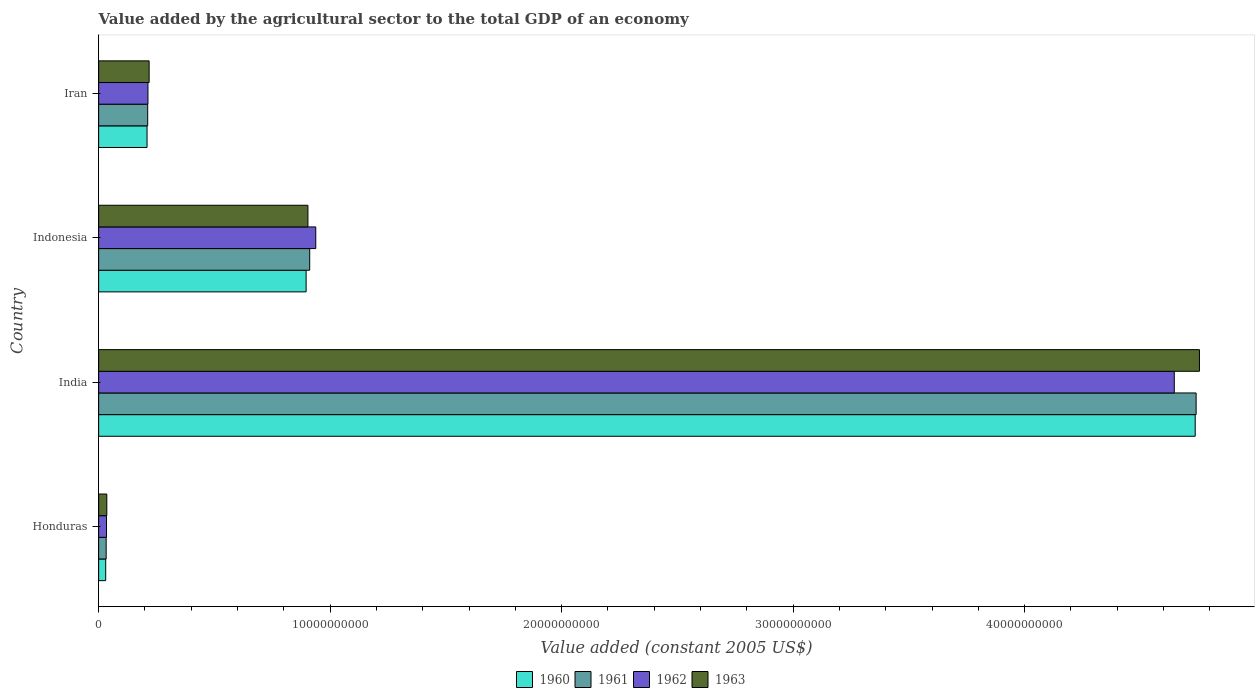How many bars are there on the 2nd tick from the bottom?
Your answer should be compact. 4. What is the label of the 4th group of bars from the top?
Give a very brief answer. Honduras. What is the value added by the agricultural sector in 1961 in Indonesia?
Offer a terse response. 9.12e+09. Across all countries, what is the maximum value added by the agricultural sector in 1963?
Ensure brevity in your answer.  4.76e+1. Across all countries, what is the minimum value added by the agricultural sector in 1961?
Provide a short and direct response. 3.25e+08. In which country was the value added by the agricultural sector in 1961 minimum?
Your response must be concise. Honduras. What is the total value added by the agricultural sector in 1963 in the graph?
Keep it short and to the point. 5.91e+1. What is the difference between the value added by the agricultural sector in 1963 in Honduras and that in Iran?
Provide a succinct answer. -1.83e+09. What is the difference between the value added by the agricultural sector in 1961 in India and the value added by the agricultural sector in 1962 in Indonesia?
Keep it short and to the point. 3.80e+1. What is the average value added by the agricultural sector in 1963 per country?
Offer a very short reply. 1.48e+1. What is the difference between the value added by the agricultural sector in 1961 and value added by the agricultural sector in 1962 in Indonesia?
Ensure brevity in your answer.  -2.62e+08. In how many countries, is the value added by the agricultural sector in 1963 greater than 42000000000 US$?
Provide a succinct answer. 1. What is the ratio of the value added by the agricultural sector in 1962 in Honduras to that in Indonesia?
Offer a terse response. 0.04. Is the difference between the value added by the agricultural sector in 1961 in Honduras and India greater than the difference between the value added by the agricultural sector in 1962 in Honduras and India?
Offer a terse response. No. What is the difference between the highest and the second highest value added by the agricultural sector in 1961?
Ensure brevity in your answer.  3.83e+1. What is the difference between the highest and the lowest value added by the agricultural sector in 1961?
Your response must be concise. 4.71e+1. In how many countries, is the value added by the agricultural sector in 1960 greater than the average value added by the agricultural sector in 1960 taken over all countries?
Your answer should be very brief. 1. Is it the case that in every country, the sum of the value added by the agricultural sector in 1961 and value added by the agricultural sector in 1960 is greater than the sum of value added by the agricultural sector in 1962 and value added by the agricultural sector in 1963?
Your answer should be compact. No. What does the 1st bar from the top in India represents?
Your response must be concise. 1963. What does the 3rd bar from the bottom in Iran represents?
Your response must be concise. 1962. How many countries are there in the graph?
Your response must be concise. 4. What is the difference between two consecutive major ticks on the X-axis?
Provide a succinct answer. 1.00e+1. How are the legend labels stacked?
Ensure brevity in your answer.  Horizontal. What is the title of the graph?
Give a very brief answer. Value added by the agricultural sector to the total GDP of an economy. Does "1984" appear as one of the legend labels in the graph?
Your answer should be compact. No. What is the label or title of the X-axis?
Provide a short and direct response. Value added (constant 2005 US$). What is the label or title of the Y-axis?
Make the answer very short. Country. What is the Value added (constant 2005 US$) of 1960 in Honduras?
Offer a terse response. 3.05e+08. What is the Value added (constant 2005 US$) of 1961 in Honduras?
Offer a terse response. 3.25e+08. What is the Value added (constant 2005 US$) in 1962 in Honduras?
Give a very brief answer. 3.41e+08. What is the Value added (constant 2005 US$) of 1963 in Honduras?
Your response must be concise. 3.53e+08. What is the Value added (constant 2005 US$) of 1960 in India?
Provide a short and direct response. 4.74e+1. What is the Value added (constant 2005 US$) in 1961 in India?
Make the answer very short. 4.74e+1. What is the Value added (constant 2005 US$) in 1962 in India?
Give a very brief answer. 4.65e+1. What is the Value added (constant 2005 US$) of 1963 in India?
Ensure brevity in your answer.  4.76e+1. What is the Value added (constant 2005 US$) of 1960 in Indonesia?
Offer a very short reply. 8.96e+09. What is the Value added (constant 2005 US$) of 1961 in Indonesia?
Your response must be concise. 9.12e+09. What is the Value added (constant 2005 US$) of 1962 in Indonesia?
Make the answer very short. 9.38e+09. What is the Value added (constant 2005 US$) of 1963 in Indonesia?
Ensure brevity in your answer.  9.04e+09. What is the Value added (constant 2005 US$) of 1960 in Iran?
Offer a terse response. 2.09e+09. What is the Value added (constant 2005 US$) of 1961 in Iran?
Provide a succinct answer. 2.12e+09. What is the Value added (constant 2005 US$) in 1962 in Iran?
Ensure brevity in your answer.  2.13e+09. What is the Value added (constant 2005 US$) in 1963 in Iran?
Ensure brevity in your answer.  2.18e+09. Across all countries, what is the maximum Value added (constant 2005 US$) in 1960?
Keep it short and to the point. 4.74e+1. Across all countries, what is the maximum Value added (constant 2005 US$) of 1961?
Offer a terse response. 4.74e+1. Across all countries, what is the maximum Value added (constant 2005 US$) in 1962?
Keep it short and to the point. 4.65e+1. Across all countries, what is the maximum Value added (constant 2005 US$) in 1963?
Keep it short and to the point. 4.76e+1. Across all countries, what is the minimum Value added (constant 2005 US$) in 1960?
Keep it short and to the point. 3.05e+08. Across all countries, what is the minimum Value added (constant 2005 US$) in 1961?
Your response must be concise. 3.25e+08. Across all countries, what is the minimum Value added (constant 2005 US$) in 1962?
Your answer should be very brief. 3.41e+08. Across all countries, what is the minimum Value added (constant 2005 US$) in 1963?
Offer a terse response. 3.53e+08. What is the total Value added (constant 2005 US$) in 1960 in the graph?
Your answer should be compact. 5.87e+1. What is the total Value added (constant 2005 US$) of 1961 in the graph?
Your answer should be very brief. 5.90e+1. What is the total Value added (constant 2005 US$) in 1962 in the graph?
Your answer should be very brief. 5.83e+1. What is the total Value added (constant 2005 US$) of 1963 in the graph?
Offer a very short reply. 5.91e+1. What is the difference between the Value added (constant 2005 US$) in 1960 in Honduras and that in India?
Make the answer very short. -4.71e+1. What is the difference between the Value added (constant 2005 US$) in 1961 in Honduras and that in India?
Make the answer very short. -4.71e+1. What is the difference between the Value added (constant 2005 US$) of 1962 in Honduras and that in India?
Keep it short and to the point. -4.61e+1. What is the difference between the Value added (constant 2005 US$) in 1963 in Honduras and that in India?
Your response must be concise. -4.72e+1. What is the difference between the Value added (constant 2005 US$) in 1960 in Honduras and that in Indonesia?
Your answer should be compact. -8.66e+09. What is the difference between the Value added (constant 2005 US$) in 1961 in Honduras and that in Indonesia?
Keep it short and to the point. -8.79e+09. What is the difference between the Value added (constant 2005 US$) of 1962 in Honduras and that in Indonesia?
Keep it short and to the point. -9.04e+09. What is the difference between the Value added (constant 2005 US$) of 1963 in Honduras and that in Indonesia?
Provide a short and direct response. -8.69e+09. What is the difference between the Value added (constant 2005 US$) of 1960 in Honduras and that in Iran?
Keep it short and to the point. -1.79e+09. What is the difference between the Value added (constant 2005 US$) in 1961 in Honduras and that in Iran?
Make the answer very short. -1.79e+09. What is the difference between the Value added (constant 2005 US$) in 1962 in Honduras and that in Iran?
Make the answer very short. -1.79e+09. What is the difference between the Value added (constant 2005 US$) of 1963 in Honduras and that in Iran?
Keep it short and to the point. -1.83e+09. What is the difference between the Value added (constant 2005 US$) in 1960 in India and that in Indonesia?
Your response must be concise. 3.84e+1. What is the difference between the Value added (constant 2005 US$) of 1961 in India and that in Indonesia?
Offer a very short reply. 3.83e+1. What is the difference between the Value added (constant 2005 US$) of 1962 in India and that in Indonesia?
Ensure brevity in your answer.  3.71e+1. What is the difference between the Value added (constant 2005 US$) in 1963 in India and that in Indonesia?
Offer a terse response. 3.85e+1. What is the difference between the Value added (constant 2005 US$) in 1960 in India and that in Iran?
Your answer should be compact. 4.53e+1. What is the difference between the Value added (constant 2005 US$) in 1961 in India and that in Iran?
Provide a succinct answer. 4.53e+1. What is the difference between the Value added (constant 2005 US$) in 1962 in India and that in Iran?
Provide a short and direct response. 4.43e+1. What is the difference between the Value added (constant 2005 US$) in 1963 in India and that in Iran?
Offer a terse response. 4.54e+1. What is the difference between the Value added (constant 2005 US$) of 1960 in Indonesia and that in Iran?
Your response must be concise. 6.87e+09. What is the difference between the Value added (constant 2005 US$) in 1961 in Indonesia and that in Iran?
Your answer should be compact. 7.00e+09. What is the difference between the Value added (constant 2005 US$) of 1962 in Indonesia and that in Iran?
Offer a very short reply. 7.25e+09. What is the difference between the Value added (constant 2005 US$) of 1963 in Indonesia and that in Iran?
Your answer should be very brief. 6.86e+09. What is the difference between the Value added (constant 2005 US$) in 1960 in Honduras and the Value added (constant 2005 US$) in 1961 in India?
Provide a succinct answer. -4.71e+1. What is the difference between the Value added (constant 2005 US$) of 1960 in Honduras and the Value added (constant 2005 US$) of 1962 in India?
Provide a succinct answer. -4.62e+1. What is the difference between the Value added (constant 2005 US$) in 1960 in Honduras and the Value added (constant 2005 US$) in 1963 in India?
Provide a short and direct response. -4.72e+1. What is the difference between the Value added (constant 2005 US$) in 1961 in Honduras and the Value added (constant 2005 US$) in 1962 in India?
Your answer should be very brief. -4.61e+1. What is the difference between the Value added (constant 2005 US$) of 1961 in Honduras and the Value added (constant 2005 US$) of 1963 in India?
Provide a succinct answer. -4.72e+1. What is the difference between the Value added (constant 2005 US$) of 1962 in Honduras and the Value added (constant 2005 US$) of 1963 in India?
Offer a terse response. -4.72e+1. What is the difference between the Value added (constant 2005 US$) in 1960 in Honduras and the Value added (constant 2005 US$) in 1961 in Indonesia?
Your answer should be compact. -8.81e+09. What is the difference between the Value added (constant 2005 US$) in 1960 in Honduras and the Value added (constant 2005 US$) in 1962 in Indonesia?
Offer a terse response. -9.07e+09. What is the difference between the Value added (constant 2005 US$) of 1960 in Honduras and the Value added (constant 2005 US$) of 1963 in Indonesia?
Your response must be concise. -8.73e+09. What is the difference between the Value added (constant 2005 US$) in 1961 in Honduras and the Value added (constant 2005 US$) in 1962 in Indonesia?
Keep it short and to the point. -9.05e+09. What is the difference between the Value added (constant 2005 US$) in 1961 in Honduras and the Value added (constant 2005 US$) in 1963 in Indonesia?
Ensure brevity in your answer.  -8.72e+09. What is the difference between the Value added (constant 2005 US$) of 1962 in Honduras and the Value added (constant 2005 US$) of 1963 in Indonesia?
Offer a very short reply. -8.70e+09. What is the difference between the Value added (constant 2005 US$) of 1960 in Honduras and the Value added (constant 2005 US$) of 1961 in Iran?
Ensure brevity in your answer.  -1.81e+09. What is the difference between the Value added (constant 2005 US$) of 1960 in Honduras and the Value added (constant 2005 US$) of 1962 in Iran?
Offer a terse response. -1.82e+09. What is the difference between the Value added (constant 2005 US$) of 1960 in Honduras and the Value added (constant 2005 US$) of 1963 in Iran?
Make the answer very short. -1.88e+09. What is the difference between the Value added (constant 2005 US$) of 1961 in Honduras and the Value added (constant 2005 US$) of 1962 in Iran?
Make the answer very short. -1.80e+09. What is the difference between the Value added (constant 2005 US$) in 1961 in Honduras and the Value added (constant 2005 US$) in 1963 in Iran?
Offer a terse response. -1.86e+09. What is the difference between the Value added (constant 2005 US$) in 1962 in Honduras and the Value added (constant 2005 US$) in 1963 in Iran?
Provide a short and direct response. -1.84e+09. What is the difference between the Value added (constant 2005 US$) in 1960 in India and the Value added (constant 2005 US$) in 1961 in Indonesia?
Ensure brevity in your answer.  3.83e+1. What is the difference between the Value added (constant 2005 US$) in 1960 in India and the Value added (constant 2005 US$) in 1962 in Indonesia?
Provide a short and direct response. 3.80e+1. What is the difference between the Value added (constant 2005 US$) in 1960 in India and the Value added (constant 2005 US$) in 1963 in Indonesia?
Provide a short and direct response. 3.83e+1. What is the difference between the Value added (constant 2005 US$) of 1961 in India and the Value added (constant 2005 US$) of 1962 in Indonesia?
Offer a very short reply. 3.80e+1. What is the difference between the Value added (constant 2005 US$) in 1961 in India and the Value added (constant 2005 US$) in 1963 in Indonesia?
Provide a succinct answer. 3.84e+1. What is the difference between the Value added (constant 2005 US$) of 1962 in India and the Value added (constant 2005 US$) of 1963 in Indonesia?
Ensure brevity in your answer.  3.74e+1. What is the difference between the Value added (constant 2005 US$) in 1960 in India and the Value added (constant 2005 US$) in 1961 in Iran?
Make the answer very short. 4.52e+1. What is the difference between the Value added (constant 2005 US$) in 1960 in India and the Value added (constant 2005 US$) in 1962 in Iran?
Keep it short and to the point. 4.52e+1. What is the difference between the Value added (constant 2005 US$) in 1960 in India and the Value added (constant 2005 US$) in 1963 in Iran?
Your answer should be compact. 4.52e+1. What is the difference between the Value added (constant 2005 US$) in 1961 in India and the Value added (constant 2005 US$) in 1962 in Iran?
Your response must be concise. 4.53e+1. What is the difference between the Value added (constant 2005 US$) in 1961 in India and the Value added (constant 2005 US$) in 1963 in Iran?
Offer a very short reply. 4.52e+1. What is the difference between the Value added (constant 2005 US$) of 1962 in India and the Value added (constant 2005 US$) of 1963 in Iran?
Ensure brevity in your answer.  4.43e+1. What is the difference between the Value added (constant 2005 US$) of 1960 in Indonesia and the Value added (constant 2005 US$) of 1961 in Iran?
Your response must be concise. 6.84e+09. What is the difference between the Value added (constant 2005 US$) in 1960 in Indonesia and the Value added (constant 2005 US$) in 1962 in Iran?
Make the answer very short. 6.83e+09. What is the difference between the Value added (constant 2005 US$) of 1960 in Indonesia and the Value added (constant 2005 US$) of 1963 in Iran?
Ensure brevity in your answer.  6.78e+09. What is the difference between the Value added (constant 2005 US$) of 1961 in Indonesia and the Value added (constant 2005 US$) of 1962 in Iran?
Provide a short and direct response. 6.99e+09. What is the difference between the Value added (constant 2005 US$) in 1961 in Indonesia and the Value added (constant 2005 US$) in 1963 in Iran?
Make the answer very short. 6.94e+09. What is the difference between the Value added (constant 2005 US$) of 1962 in Indonesia and the Value added (constant 2005 US$) of 1963 in Iran?
Offer a very short reply. 7.20e+09. What is the average Value added (constant 2005 US$) in 1960 per country?
Offer a very short reply. 1.47e+1. What is the average Value added (constant 2005 US$) of 1961 per country?
Your answer should be very brief. 1.47e+1. What is the average Value added (constant 2005 US$) of 1962 per country?
Your answer should be very brief. 1.46e+1. What is the average Value added (constant 2005 US$) in 1963 per country?
Give a very brief answer. 1.48e+1. What is the difference between the Value added (constant 2005 US$) of 1960 and Value added (constant 2005 US$) of 1961 in Honduras?
Ensure brevity in your answer.  -1.99e+07. What is the difference between the Value added (constant 2005 US$) in 1960 and Value added (constant 2005 US$) in 1962 in Honduras?
Ensure brevity in your answer.  -3.54e+07. What is the difference between the Value added (constant 2005 US$) in 1960 and Value added (constant 2005 US$) in 1963 in Honduras?
Your answer should be compact. -4.78e+07. What is the difference between the Value added (constant 2005 US$) in 1961 and Value added (constant 2005 US$) in 1962 in Honduras?
Your answer should be compact. -1.55e+07. What is the difference between the Value added (constant 2005 US$) of 1961 and Value added (constant 2005 US$) of 1963 in Honduras?
Offer a very short reply. -2.79e+07. What is the difference between the Value added (constant 2005 US$) of 1962 and Value added (constant 2005 US$) of 1963 in Honduras?
Offer a terse response. -1.24e+07. What is the difference between the Value added (constant 2005 US$) in 1960 and Value added (constant 2005 US$) in 1961 in India?
Offer a terse response. -3.99e+07. What is the difference between the Value added (constant 2005 US$) in 1960 and Value added (constant 2005 US$) in 1962 in India?
Provide a short and direct response. 9.03e+08. What is the difference between the Value added (constant 2005 US$) in 1960 and Value added (constant 2005 US$) in 1963 in India?
Make the answer very short. -1.84e+08. What is the difference between the Value added (constant 2005 US$) in 1961 and Value added (constant 2005 US$) in 1962 in India?
Offer a terse response. 9.43e+08. What is the difference between the Value added (constant 2005 US$) in 1961 and Value added (constant 2005 US$) in 1963 in India?
Keep it short and to the point. -1.44e+08. What is the difference between the Value added (constant 2005 US$) in 1962 and Value added (constant 2005 US$) in 1963 in India?
Ensure brevity in your answer.  -1.09e+09. What is the difference between the Value added (constant 2005 US$) of 1960 and Value added (constant 2005 US$) of 1961 in Indonesia?
Your answer should be compact. -1.54e+08. What is the difference between the Value added (constant 2005 US$) of 1960 and Value added (constant 2005 US$) of 1962 in Indonesia?
Keep it short and to the point. -4.16e+08. What is the difference between the Value added (constant 2005 US$) in 1960 and Value added (constant 2005 US$) in 1963 in Indonesia?
Your response must be concise. -7.71e+07. What is the difference between the Value added (constant 2005 US$) of 1961 and Value added (constant 2005 US$) of 1962 in Indonesia?
Your response must be concise. -2.62e+08. What is the difference between the Value added (constant 2005 US$) of 1961 and Value added (constant 2005 US$) of 1963 in Indonesia?
Your answer should be compact. 7.71e+07. What is the difference between the Value added (constant 2005 US$) of 1962 and Value added (constant 2005 US$) of 1963 in Indonesia?
Make the answer very short. 3.39e+08. What is the difference between the Value added (constant 2005 US$) of 1960 and Value added (constant 2005 US$) of 1961 in Iran?
Offer a very short reply. -2.84e+07. What is the difference between the Value added (constant 2005 US$) in 1960 and Value added (constant 2005 US$) in 1962 in Iran?
Your answer should be compact. -3.89e+07. What is the difference between the Value added (constant 2005 US$) of 1960 and Value added (constant 2005 US$) of 1963 in Iran?
Your answer should be very brief. -9.02e+07. What is the difference between the Value added (constant 2005 US$) in 1961 and Value added (constant 2005 US$) in 1962 in Iran?
Your answer should be compact. -1.05e+07. What is the difference between the Value added (constant 2005 US$) of 1961 and Value added (constant 2005 US$) of 1963 in Iran?
Keep it short and to the point. -6.18e+07. What is the difference between the Value added (constant 2005 US$) in 1962 and Value added (constant 2005 US$) in 1963 in Iran?
Ensure brevity in your answer.  -5.13e+07. What is the ratio of the Value added (constant 2005 US$) in 1960 in Honduras to that in India?
Keep it short and to the point. 0.01. What is the ratio of the Value added (constant 2005 US$) in 1961 in Honduras to that in India?
Provide a succinct answer. 0.01. What is the ratio of the Value added (constant 2005 US$) of 1962 in Honduras to that in India?
Your answer should be very brief. 0.01. What is the ratio of the Value added (constant 2005 US$) in 1963 in Honduras to that in India?
Offer a very short reply. 0.01. What is the ratio of the Value added (constant 2005 US$) in 1960 in Honduras to that in Indonesia?
Your answer should be compact. 0.03. What is the ratio of the Value added (constant 2005 US$) of 1961 in Honduras to that in Indonesia?
Your answer should be very brief. 0.04. What is the ratio of the Value added (constant 2005 US$) in 1962 in Honduras to that in Indonesia?
Your response must be concise. 0.04. What is the ratio of the Value added (constant 2005 US$) in 1963 in Honduras to that in Indonesia?
Your answer should be very brief. 0.04. What is the ratio of the Value added (constant 2005 US$) of 1960 in Honduras to that in Iran?
Your answer should be very brief. 0.15. What is the ratio of the Value added (constant 2005 US$) of 1961 in Honduras to that in Iran?
Your response must be concise. 0.15. What is the ratio of the Value added (constant 2005 US$) in 1962 in Honduras to that in Iran?
Offer a very short reply. 0.16. What is the ratio of the Value added (constant 2005 US$) in 1963 in Honduras to that in Iran?
Give a very brief answer. 0.16. What is the ratio of the Value added (constant 2005 US$) in 1960 in India to that in Indonesia?
Your answer should be very brief. 5.28. What is the ratio of the Value added (constant 2005 US$) in 1961 in India to that in Indonesia?
Ensure brevity in your answer.  5.2. What is the ratio of the Value added (constant 2005 US$) in 1962 in India to that in Indonesia?
Your answer should be very brief. 4.95. What is the ratio of the Value added (constant 2005 US$) in 1963 in India to that in Indonesia?
Offer a very short reply. 5.26. What is the ratio of the Value added (constant 2005 US$) of 1960 in India to that in Iran?
Offer a very short reply. 22.65. What is the ratio of the Value added (constant 2005 US$) of 1961 in India to that in Iran?
Your answer should be very brief. 22.37. What is the ratio of the Value added (constant 2005 US$) in 1962 in India to that in Iran?
Your response must be concise. 21.81. What is the ratio of the Value added (constant 2005 US$) in 1963 in India to that in Iran?
Your response must be concise. 21.8. What is the ratio of the Value added (constant 2005 US$) in 1960 in Indonesia to that in Iran?
Your response must be concise. 4.29. What is the ratio of the Value added (constant 2005 US$) in 1961 in Indonesia to that in Iran?
Your answer should be very brief. 4.3. What is the ratio of the Value added (constant 2005 US$) of 1962 in Indonesia to that in Iran?
Keep it short and to the point. 4.4. What is the ratio of the Value added (constant 2005 US$) in 1963 in Indonesia to that in Iran?
Give a very brief answer. 4.14. What is the difference between the highest and the second highest Value added (constant 2005 US$) of 1960?
Provide a short and direct response. 3.84e+1. What is the difference between the highest and the second highest Value added (constant 2005 US$) of 1961?
Offer a very short reply. 3.83e+1. What is the difference between the highest and the second highest Value added (constant 2005 US$) in 1962?
Provide a short and direct response. 3.71e+1. What is the difference between the highest and the second highest Value added (constant 2005 US$) of 1963?
Your answer should be compact. 3.85e+1. What is the difference between the highest and the lowest Value added (constant 2005 US$) in 1960?
Offer a very short reply. 4.71e+1. What is the difference between the highest and the lowest Value added (constant 2005 US$) in 1961?
Your answer should be compact. 4.71e+1. What is the difference between the highest and the lowest Value added (constant 2005 US$) of 1962?
Ensure brevity in your answer.  4.61e+1. What is the difference between the highest and the lowest Value added (constant 2005 US$) in 1963?
Give a very brief answer. 4.72e+1. 